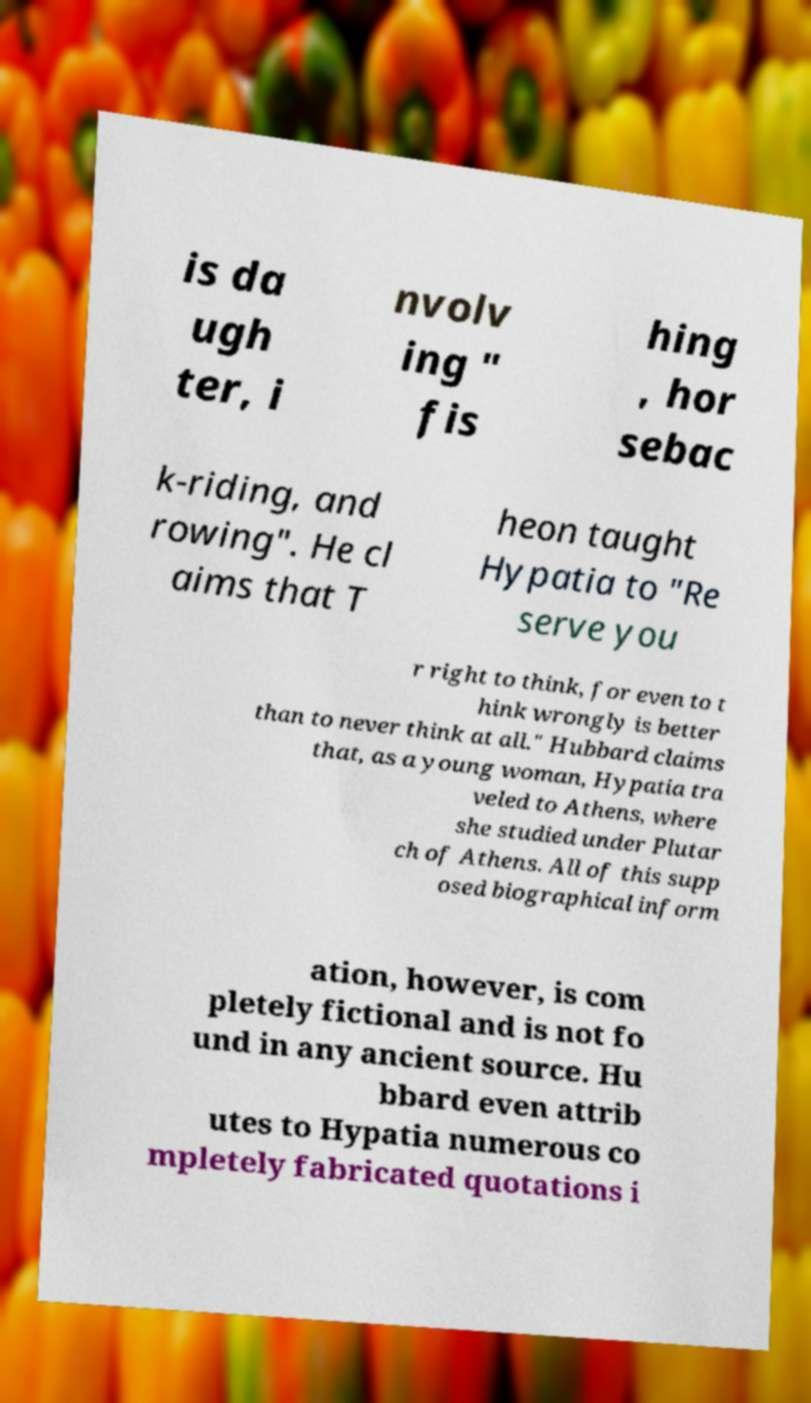Could you assist in decoding the text presented in this image and type it out clearly? is da ugh ter, i nvolv ing " fis hing , hor sebac k-riding, and rowing". He cl aims that T heon taught Hypatia to "Re serve you r right to think, for even to t hink wrongly is better than to never think at all." Hubbard claims that, as a young woman, Hypatia tra veled to Athens, where she studied under Plutar ch of Athens. All of this supp osed biographical inform ation, however, is com pletely fictional and is not fo und in any ancient source. Hu bbard even attrib utes to Hypatia numerous co mpletely fabricated quotations i 